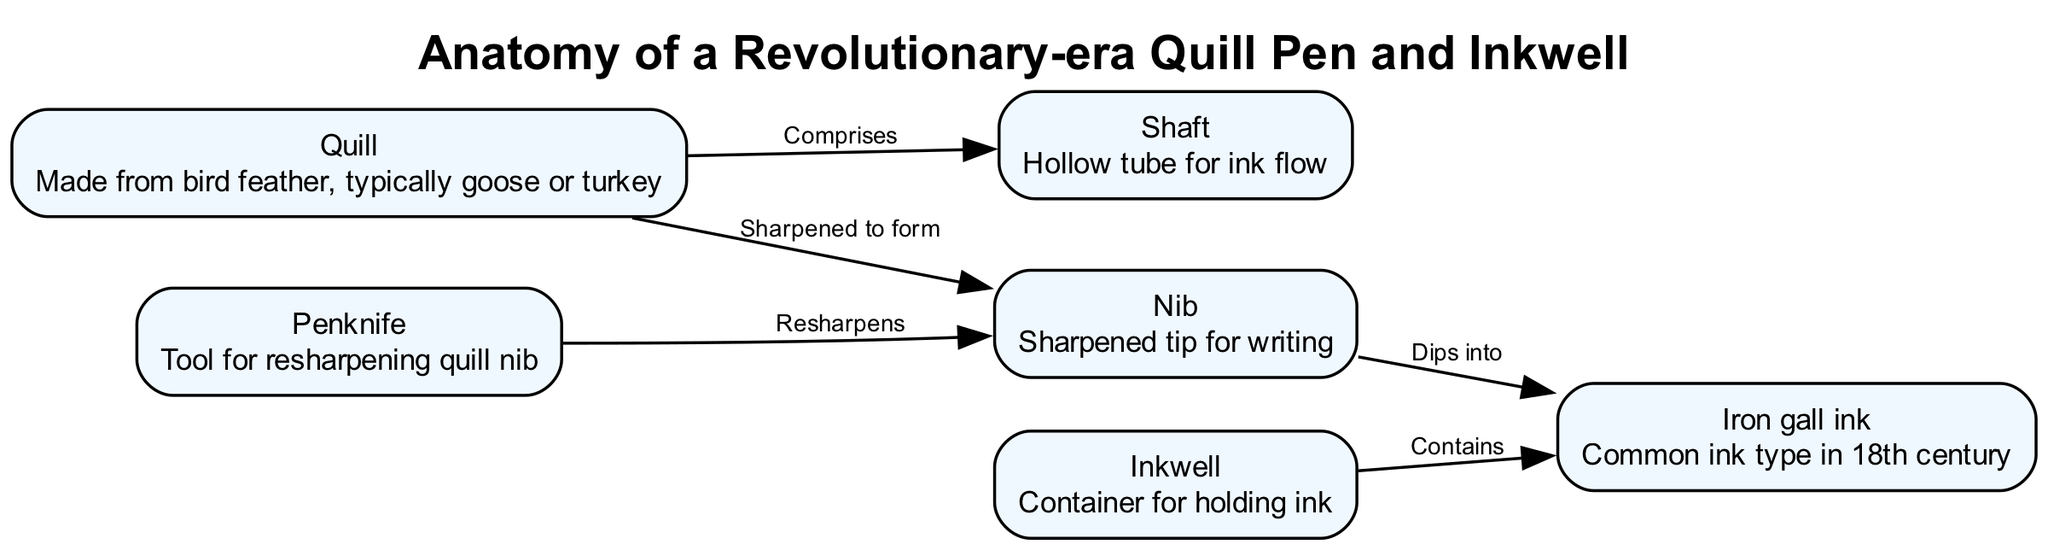What is the material used to make the quill? The diagram states that the quill is made from a bird feather, typically goose or turkey. This information is directly associated with the quill node in the diagram.
Answer: Bird feather What is contained within the inkwell? According to the diagram, the inkwell contains ink. This relationship is indicated through the edge connecting the inkwell and ink nodes.
Answer: Ink How many nodes are present in the diagram? By counting each unique node listed in the diagram, we find there are six nodes: quill, nib, shaft, inkwell, ink, and penknife. Therefore, the total count is six.
Answer: 6 What does the nib do? The nib, as shown in the diagram, dips into the ink, which is a function highlighted by the edge connecting the nib to the ink node. This means the nib is responsible for drawing ink for writing.
Answer: Dips into ink What tool is used to resharpen the quill nib? The diagram specifies that the penknife is the tool used for resharpening the quill nib, indicated by the edge linking the penknife and the nib node.
Answer: Penknife What is the function of the shaft in the quill pen? The shaft serves as a hollow tube for ink flow, as described in the shaft node of the diagram. This detail explains the role of the shaft in the writing process.
Answer: Hollow tube for ink flow How is the nib formed? The nib is formed by sharpening the quill, as represented by the edge that states "sharpened to form" between the quill and nib nodes. This implies a transformation process where the quill is modified to create the nib.
Answer: Sharpened to form Which type of ink was commonly used in the 18th century? The diagram identifies "iron gall ink" as the common ink type in the 18th century, which is directly described in the ink node. This specific type of ink is critical to understanding the writing tools of the era.
Answer: Iron gall ink What connects the quill and the shaft? The diagram indicates that the quill comprises the shaft, as shown by the connecting edge between these two nodes. This relationship defines a structural component of the quill pen.
Answer: Comprises 